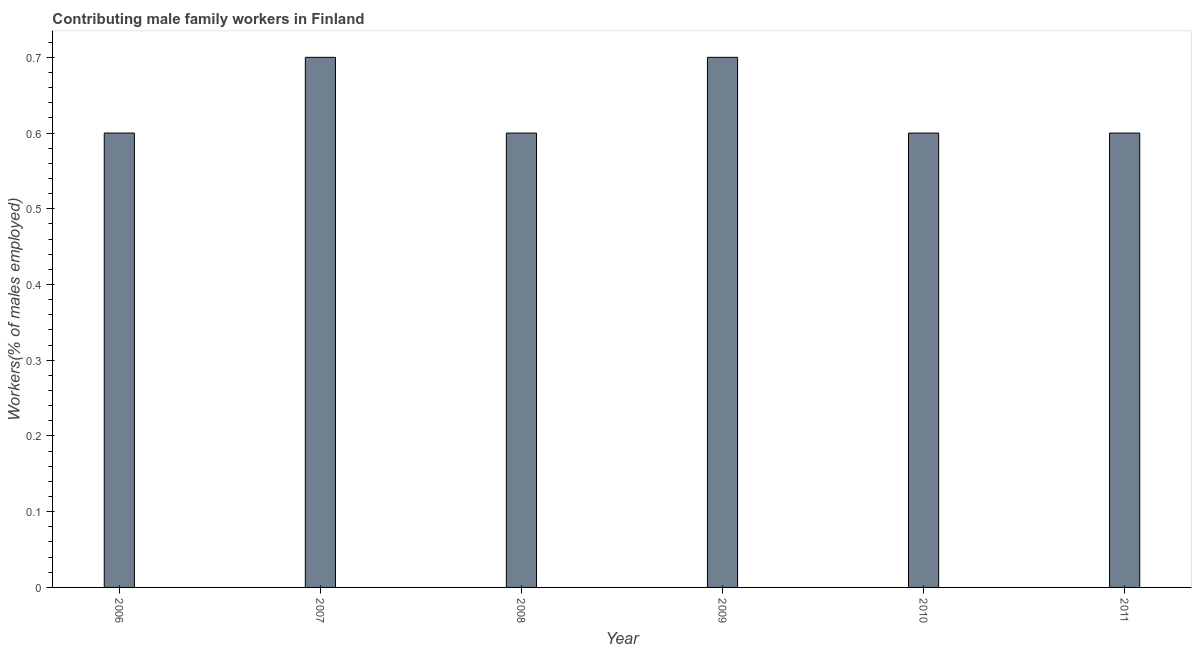What is the title of the graph?
Make the answer very short. Contributing male family workers in Finland. What is the label or title of the Y-axis?
Keep it short and to the point. Workers(% of males employed). What is the contributing male family workers in 2008?
Ensure brevity in your answer.  0.6. Across all years, what is the maximum contributing male family workers?
Keep it short and to the point. 0.7. Across all years, what is the minimum contributing male family workers?
Give a very brief answer. 0.6. In which year was the contributing male family workers minimum?
Make the answer very short. 2006. What is the sum of the contributing male family workers?
Offer a terse response. 3.8. What is the average contributing male family workers per year?
Provide a succinct answer. 0.63. What is the median contributing male family workers?
Your answer should be very brief. 0.6. In how many years, is the contributing male family workers greater than 0.02 %?
Offer a terse response. 6. Do a majority of the years between 2008 and 2009 (inclusive) have contributing male family workers greater than 0.16 %?
Offer a terse response. Yes. What is the ratio of the contributing male family workers in 2006 to that in 2009?
Give a very brief answer. 0.86. What is the difference between the highest and the second highest contributing male family workers?
Offer a very short reply. 0. What is the difference between the highest and the lowest contributing male family workers?
Your response must be concise. 0.1. How many bars are there?
Offer a very short reply. 6. How many years are there in the graph?
Your answer should be very brief. 6. What is the difference between two consecutive major ticks on the Y-axis?
Make the answer very short. 0.1. What is the Workers(% of males employed) of 2006?
Your answer should be compact. 0.6. What is the Workers(% of males employed) of 2007?
Your response must be concise. 0.7. What is the Workers(% of males employed) in 2008?
Keep it short and to the point. 0.6. What is the Workers(% of males employed) of 2009?
Your answer should be very brief. 0.7. What is the Workers(% of males employed) in 2010?
Offer a terse response. 0.6. What is the Workers(% of males employed) in 2011?
Your response must be concise. 0.6. What is the difference between the Workers(% of males employed) in 2006 and 2007?
Provide a succinct answer. -0.1. What is the difference between the Workers(% of males employed) in 2006 and 2010?
Ensure brevity in your answer.  0. What is the difference between the Workers(% of males employed) in 2007 and 2008?
Offer a very short reply. 0.1. What is the difference between the Workers(% of males employed) in 2007 and 2010?
Ensure brevity in your answer.  0.1. What is the difference between the Workers(% of males employed) in 2007 and 2011?
Ensure brevity in your answer.  0.1. What is the difference between the Workers(% of males employed) in 2008 and 2009?
Ensure brevity in your answer.  -0.1. What is the difference between the Workers(% of males employed) in 2009 and 2010?
Your answer should be very brief. 0.1. What is the difference between the Workers(% of males employed) in 2009 and 2011?
Keep it short and to the point. 0.1. What is the difference between the Workers(% of males employed) in 2010 and 2011?
Provide a succinct answer. 0. What is the ratio of the Workers(% of males employed) in 2006 to that in 2007?
Offer a terse response. 0.86. What is the ratio of the Workers(% of males employed) in 2006 to that in 2009?
Keep it short and to the point. 0.86. What is the ratio of the Workers(% of males employed) in 2006 to that in 2010?
Provide a succinct answer. 1. What is the ratio of the Workers(% of males employed) in 2006 to that in 2011?
Your answer should be very brief. 1. What is the ratio of the Workers(% of males employed) in 2007 to that in 2008?
Provide a succinct answer. 1.17. What is the ratio of the Workers(% of males employed) in 2007 to that in 2010?
Your answer should be compact. 1.17. What is the ratio of the Workers(% of males employed) in 2007 to that in 2011?
Provide a short and direct response. 1.17. What is the ratio of the Workers(% of males employed) in 2008 to that in 2009?
Make the answer very short. 0.86. What is the ratio of the Workers(% of males employed) in 2008 to that in 2011?
Keep it short and to the point. 1. What is the ratio of the Workers(% of males employed) in 2009 to that in 2010?
Ensure brevity in your answer.  1.17. What is the ratio of the Workers(% of males employed) in 2009 to that in 2011?
Ensure brevity in your answer.  1.17. What is the ratio of the Workers(% of males employed) in 2010 to that in 2011?
Keep it short and to the point. 1. 